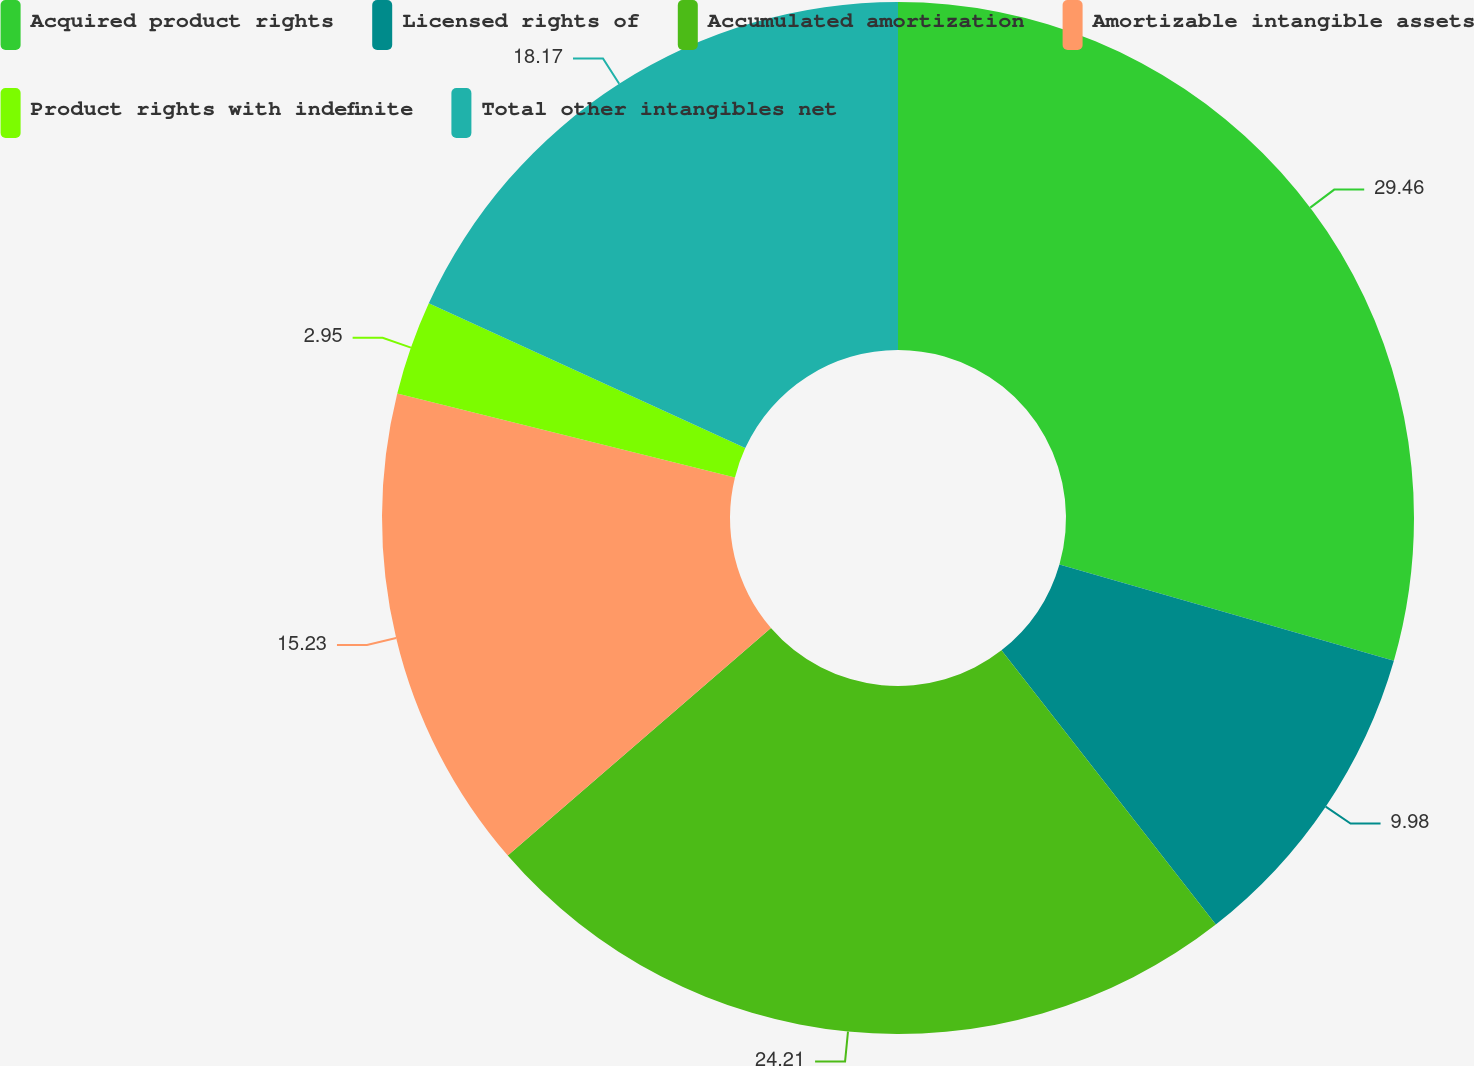Convert chart. <chart><loc_0><loc_0><loc_500><loc_500><pie_chart><fcel>Acquired product rights<fcel>Licensed rights of<fcel>Accumulated amortization<fcel>Amortizable intangible assets<fcel>Product rights with indefinite<fcel>Total other intangibles net<nl><fcel>29.46%<fcel>9.98%<fcel>24.21%<fcel>15.23%<fcel>2.95%<fcel>18.17%<nl></chart> 